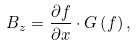<formula> <loc_0><loc_0><loc_500><loc_500>B _ { z } = \frac { \partial f } { \partial x } \cdot G \left ( f \right ) ,</formula> 